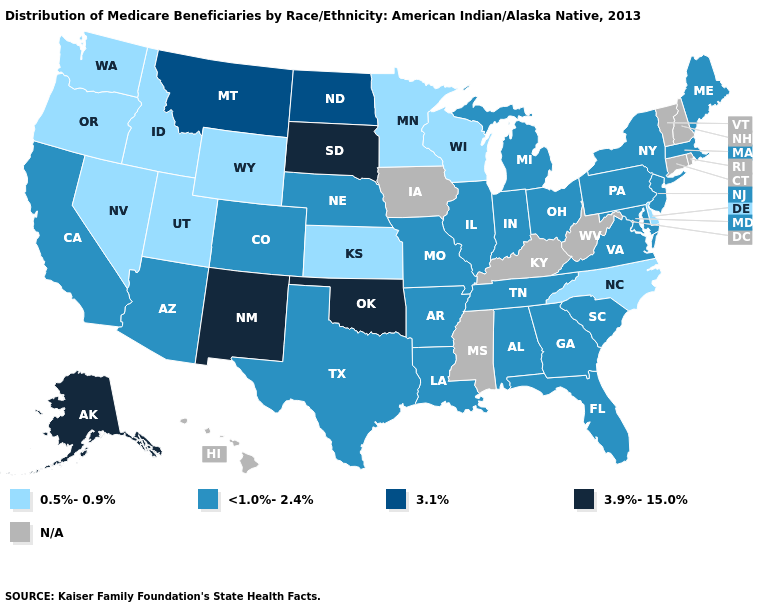Which states have the highest value in the USA?
Be succinct. Alaska, New Mexico, Oklahoma, South Dakota. Name the states that have a value in the range 3.9%-15.0%?
Be succinct. Alaska, New Mexico, Oklahoma, South Dakota. Which states have the lowest value in the South?
Short answer required. Delaware, North Carolina. What is the value of New York?
Short answer required. <1.0%-2.4%. How many symbols are there in the legend?
Short answer required. 5. Does Kansas have the lowest value in the MidWest?
Quick response, please. Yes. What is the value of Iowa?
Answer briefly. N/A. What is the value of Maryland?
Short answer required. <1.0%-2.4%. What is the value of Virginia?
Give a very brief answer. <1.0%-2.4%. Does the first symbol in the legend represent the smallest category?
Concise answer only. Yes. What is the value of North Carolina?
Write a very short answer. 0.5%-0.9%. Does the map have missing data?
Be succinct. Yes. Name the states that have a value in the range <1.0%-2.4%?
Answer briefly. Alabama, Arizona, Arkansas, California, Colorado, Florida, Georgia, Illinois, Indiana, Louisiana, Maine, Maryland, Massachusetts, Michigan, Missouri, Nebraska, New Jersey, New York, Ohio, Pennsylvania, South Carolina, Tennessee, Texas, Virginia. How many symbols are there in the legend?
Concise answer only. 5. Does the first symbol in the legend represent the smallest category?
Concise answer only. Yes. 